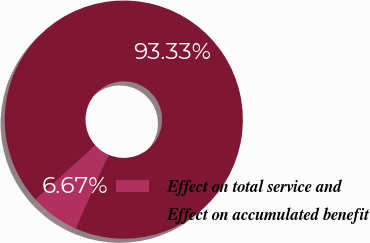Convert chart. <chart><loc_0><loc_0><loc_500><loc_500><pie_chart><fcel>Effect on total service and<fcel>Effect on accumulated benefit<nl><fcel>6.67%<fcel>93.33%<nl></chart> 